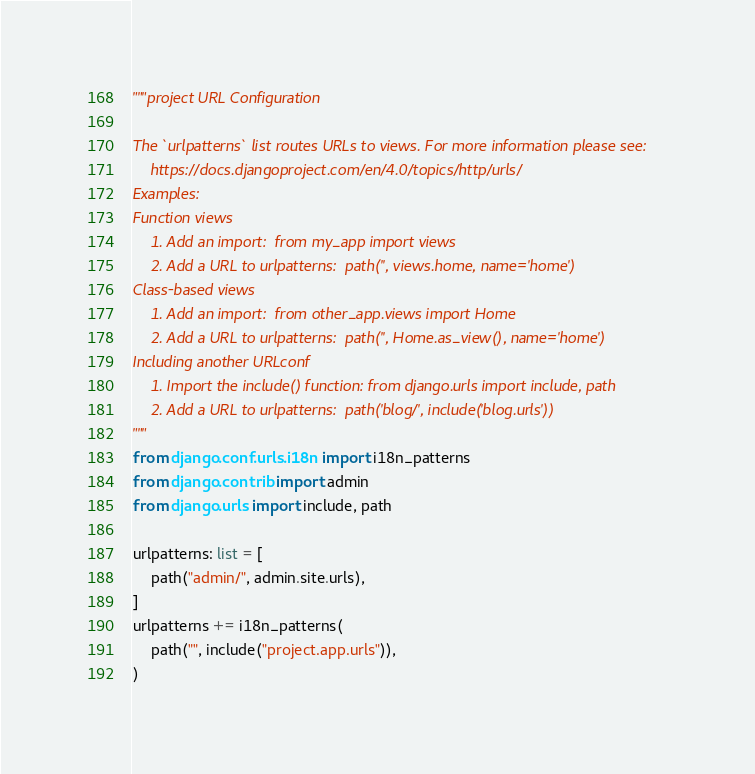<code> <loc_0><loc_0><loc_500><loc_500><_Python_>"""project URL Configuration

The `urlpatterns` list routes URLs to views. For more information please see:
    https://docs.djangoproject.com/en/4.0/topics/http/urls/
Examples:
Function views
    1. Add an import:  from my_app import views
    2. Add a URL to urlpatterns:  path('', views.home, name='home')
Class-based views
    1. Add an import:  from other_app.views import Home
    2. Add a URL to urlpatterns:  path('', Home.as_view(), name='home')
Including another URLconf
    1. Import the include() function: from django.urls import include, path
    2. Add a URL to urlpatterns:  path('blog/', include('blog.urls'))
"""
from django.conf.urls.i18n import i18n_patterns
from django.contrib import admin
from django.urls import include, path

urlpatterns: list = [
    path("admin/", admin.site.urls),
]
urlpatterns += i18n_patterns(
    path("", include("project.app.urls")),
)
</code> 